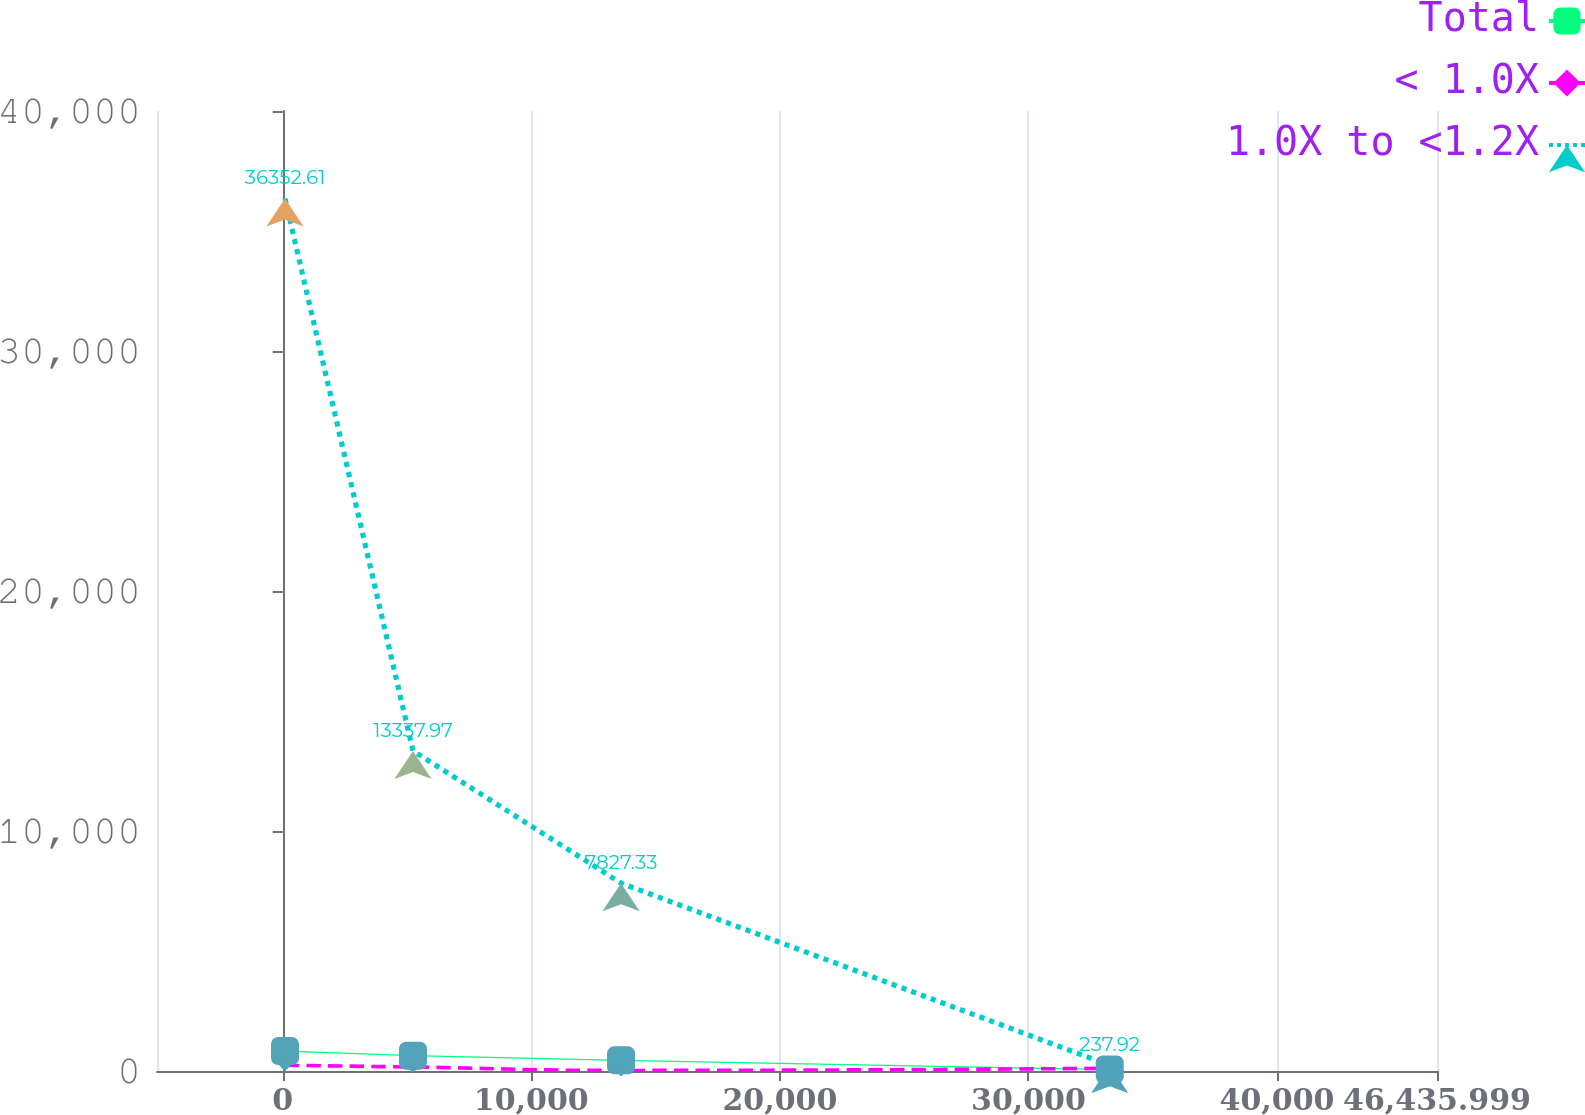Convert chart to OTSL. <chart><loc_0><loc_0><loc_500><loc_500><line_chart><ecel><fcel>Total<fcel>< 1.0X<fcel>1.0X to <1.2X<nl><fcel>92.65<fcel>831.73<fcel>237.19<fcel>36352.6<nl><fcel>5241.91<fcel>637.37<fcel>165.24<fcel>13338<nl><fcel>13611<fcel>443.01<fcel>23.56<fcel>7827.33<nl><fcel>33272<fcel>60.97<fcel>113.68<fcel>237.92<nl><fcel>51585.3<fcel>2004.6<fcel>539.16<fcel>55344.3<nl></chart> 